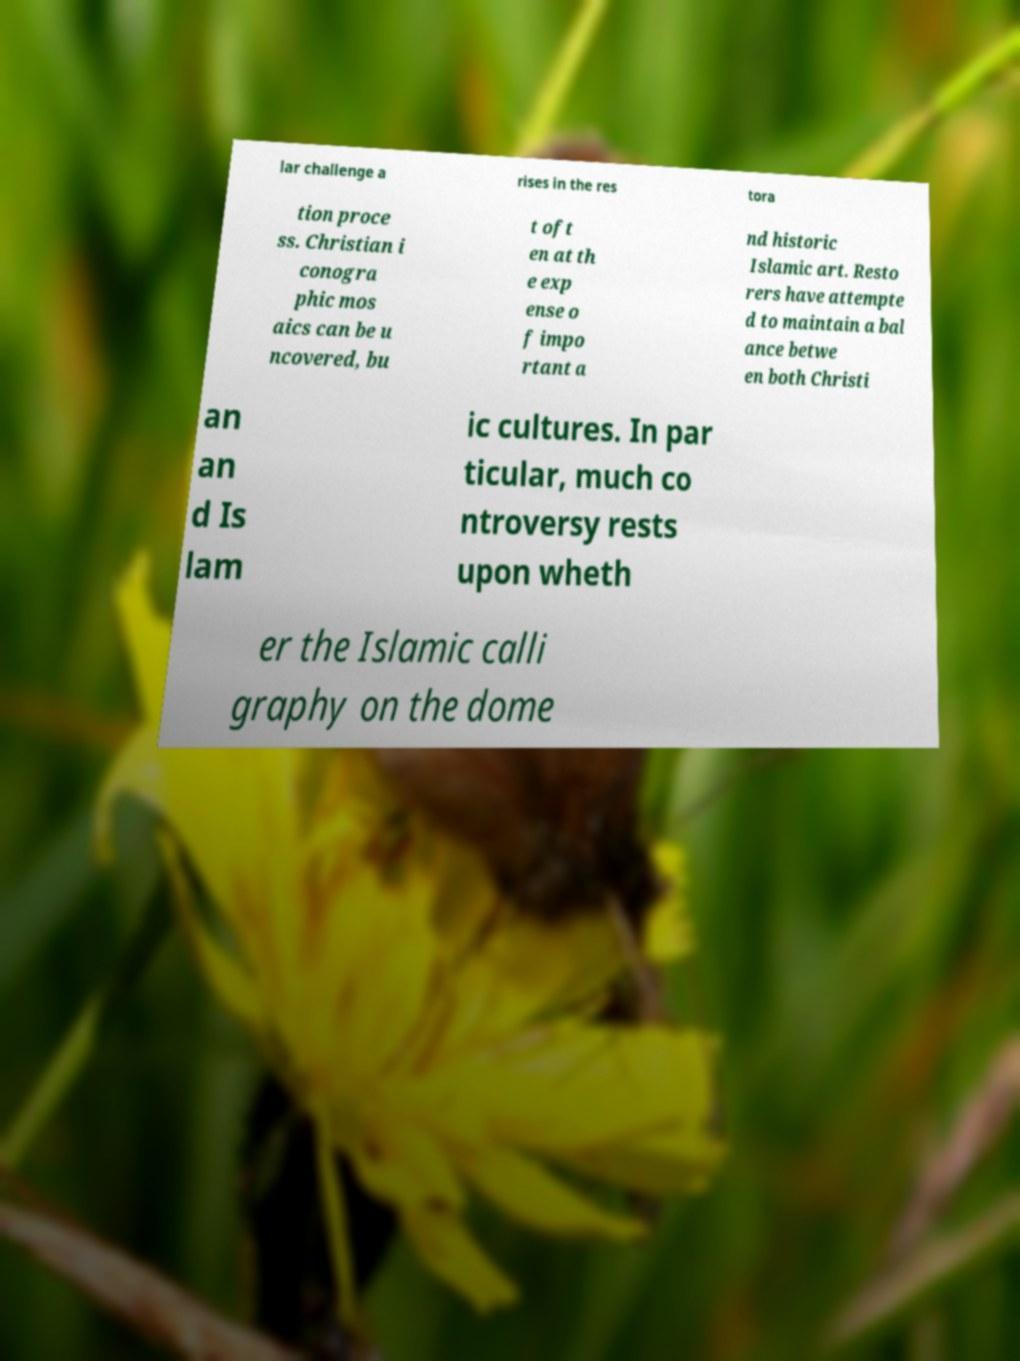I need the written content from this picture converted into text. Can you do that? lar challenge a rises in the res tora tion proce ss. Christian i conogra phic mos aics can be u ncovered, bu t oft en at th e exp ense o f impo rtant a nd historic Islamic art. Resto rers have attempte d to maintain a bal ance betwe en both Christi an an d Is lam ic cultures. In par ticular, much co ntroversy rests upon wheth er the Islamic calli graphy on the dome 